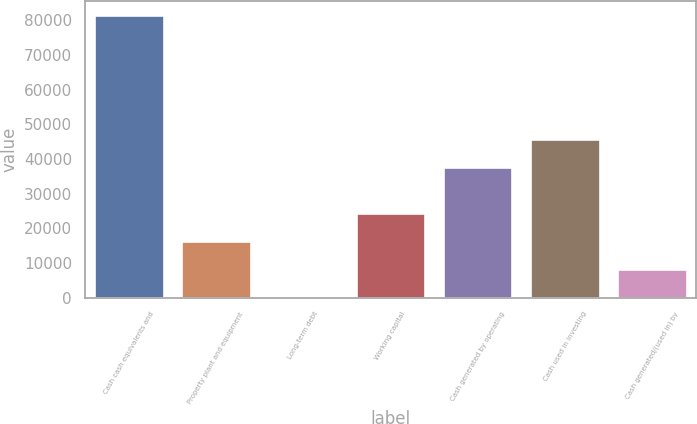Convert chart. <chart><loc_0><loc_0><loc_500><loc_500><bar_chart><fcel>Cash cash equivalents and<fcel>Property plant and equipment<fcel>Long-term debt<fcel>Working capital<fcel>Cash generated by operating<fcel>Cash used in investing<fcel>Cash generated/(used in) by<nl><fcel>81570<fcel>16315.5<fcel>1.84<fcel>24472.3<fcel>37529<fcel>45685.8<fcel>8158.66<nl></chart> 